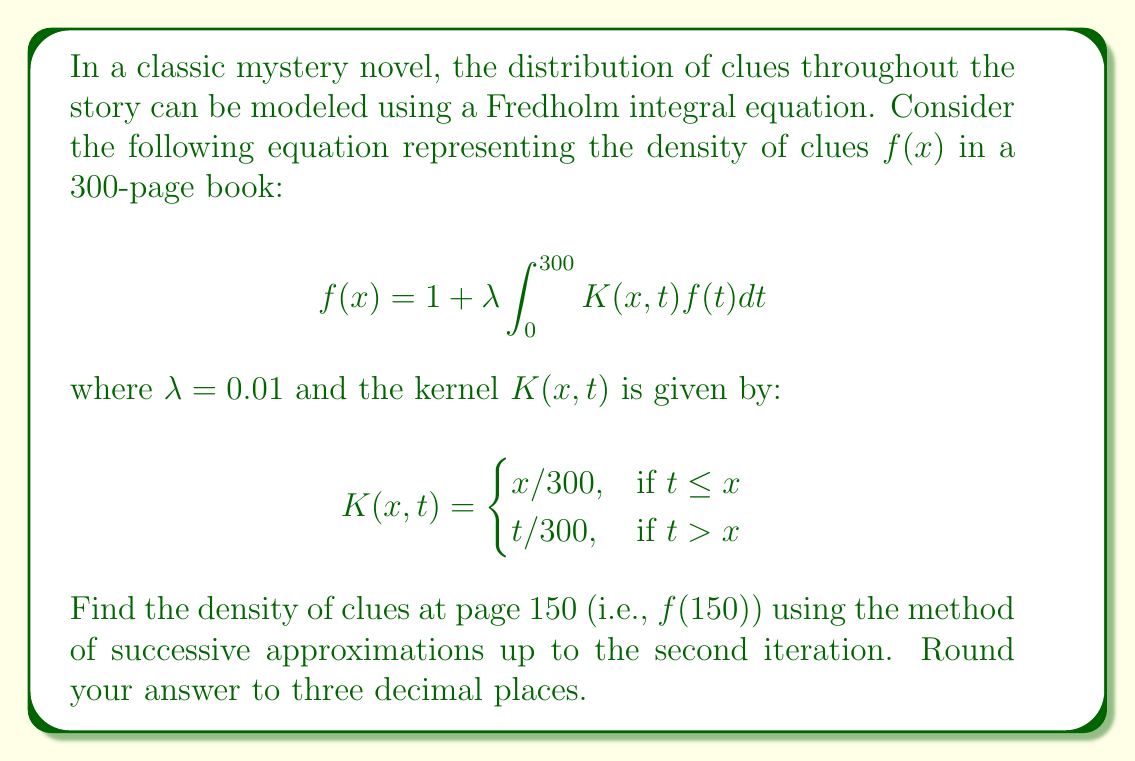Can you answer this question? Let's solve this step-by-step using the method of successive approximations:

1) We start with the initial approximation $f_0(x) = 1$ for all $x$.

2) For the first iteration, we substitute $f_0(x)$ into the right-hand side of the equation:

   $$f_1(x) = 1 + 0.01 \int_0^{300} K(x,t)dt$$

3) We need to evaluate this integral at $x = 150$:

   $$f_1(150) = 1 + 0.01 \left(\int_0^{150} \frac{150}{300}dt + \int_{150}^{300} \frac{t}{300}dt\right)$$

4) Evaluating these integrals:

   $$f_1(150) = 1 + 0.01 \left(\frac{150}{300} \cdot 150 + \left[\frac{t^2}{600}\right]_{150}^{300}\right)$$
   $$f_1(150) = 1 + 0.01 (75 + 75) = 1 + 1.5 = 2.5$$

5) For the second iteration, we use $f_1(x)$ in the integral:

   $$f_2(x) = 1 + 0.01 \int_0^{300} K(x,t)f_1(t)dt$$

6) At $x = 150$, this becomes:

   $$f_2(150) = 1 + 0.01 \left(\int_0^{150} \frac{150}{300} \cdot 2.5dt + \int_{150}^{300} \frac{t}{300} \cdot 2.5dt\right)$$

7) Evaluating these integrals:

   $$f_2(150) = 1 + 0.01 \left(\frac{150}{300} \cdot 2.5 \cdot 150 + 2.5 \cdot \left[\frac{t^2}{600}\right]_{150}^{300}\right)$$
   $$f_2(150) = 1 + 0.01 (187.5 + 187.5) = 1 + 3.75 = 4.75$$

8) Rounding to three decimal places, we get 4.750.
Answer: 4.750 